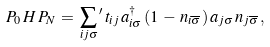<formula> <loc_0><loc_0><loc_500><loc_500>P _ { 0 } \, H \, P _ { N } \, = \, \sum _ { i j \sigma } { ^ { \prime } } \, t _ { i j } \, a _ { i \sigma } ^ { \dagger } \, ( 1 \, - \, n _ { i \overline { \sigma } } ) \, a _ { j \sigma } \, n _ { j \overline { \sigma } } \, ,</formula> 